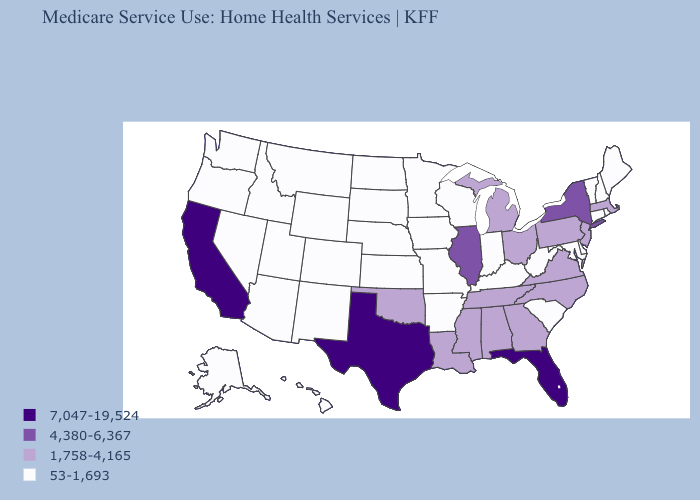What is the value of Alabama?
Quick response, please. 1,758-4,165. Does Kansas have the same value as Georgia?
Quick response, please. No. Which states have the highest value in the USA?
Concise answer only. California, Florida, Texas. Which states have the highest value in the USA?
Answer briefly. California, Florida, Texas. Name the states that have a value in the range 4,380-6,367?
Short answer required. Illinois, New York. What is the highest value in states that border South Dakota?
Write a very short answer. 53-1,693. Name the states that have a value in the range 7,047-19,524?
Quick response, please. California, Florida, Texas. Among the states that border Indiana , which have the highest value?
Be succinct. Illinois. What is the lowest value in the USA?
Answer briefly. 53-1,693. Does the first symbol in the legend represent the smallest category?
Quick response, please. No. What is the lowest value in states that border North Dakota?
Write a very short answer. 53-1,693. Among the states that border Illinois , which have the highest value?
Quick response, please. Indiana, Iowa, Kentucky, Missouri, Wisconsin. What is the highest value in the South ?
Short answer required. 7,047-19,524. What is the value of Idaho?
Keep it brief. 53-1,693. 